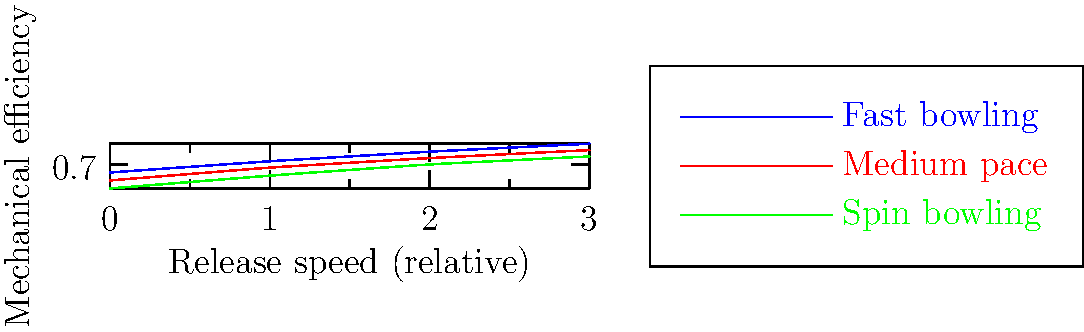Based on the graph showing the mechanical efficiency of different bowling actions in cricket, which bowling style appears to have the highest mechanical efficiency across all release speeds? To answer this question, we need to analyze the graph step-by-step:

1. The graph shows three different bowling styles: fast bowling (blue), medium pace (red), and spin bowling (green).

2. The x-axis represents the relative release speed, ranging from 0 to 3.

3. The y-axis represents the mechanical efficiency, ranging from approximately 0.55 to 0.83.

4. We need to compare the position of each line on the graph:
   a) The blue line (fast bowling) is consistently higher than the other two lines.
   b) The red line (medium pace) is in the middle.
   c) The green line (spin bowling) is the lowest.

5. This positioning remains consistent across all release speeds (x-axis values).

6. The higher the line on the graph, the greater the mechanical efficiency.

Therefore, fast bowling (represented by the blue line) consistently shows the highest mechanical efficiency across all release speeds.
Answer: Fast bowling 